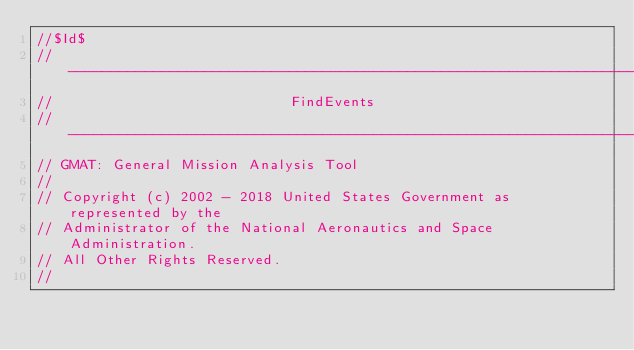Convert code to text. <code><loc_0><loc_0><loc_500><loc_500><_C++_>//$Id$
//------------------------------------------------------------------------------
//                            FindEvents
//------------------------------------------------------------------------------
// GMAT: General Mission Analysis Tool
//
// Copyright (c) 2002 - 2018 United States Government as represented by the
// Administrator of the National Aeronautics and Space Administration.
// All Other Rights Reserved.
//</code> 